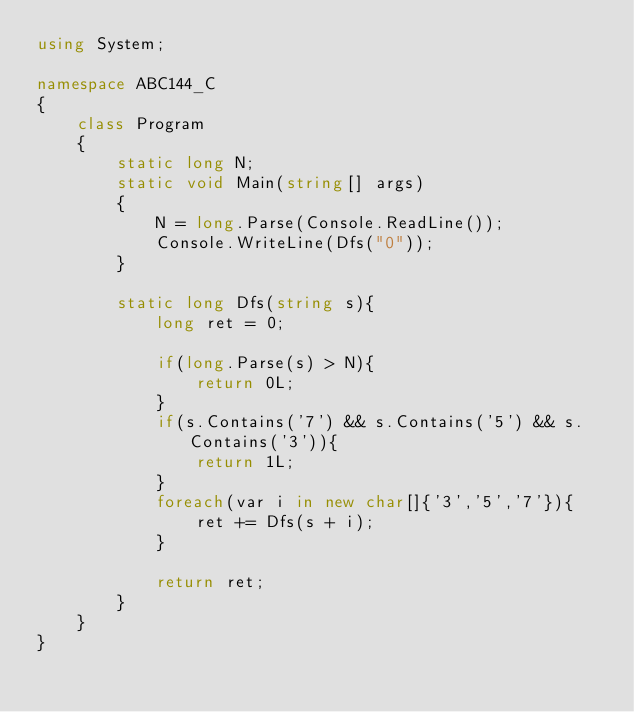<code> <loc_0><loc_0><loc_500><loc_500><_C#_>using System;

namespace ABC144_C
{
    class Program
    {
        static long N;
        static void Main(string[] args)
        {
            N = long.Parse(Console.ReadLine());
            Console.WriteLine(Dfs("0"));
        }

        static long Dfs(string s){
            long ret = 0;

            if(long.Parse(s) > N){
                return 0L;
            }
            if(s.Contains('7') && s.Contains('5') && s.Contains('3')){
                return 1L;
            }
            foreach(var i in new char[]{'3','5','7'}){
                ret += Dfs(s + i);
            }

            return ret;
        }
    }
}
</code> 